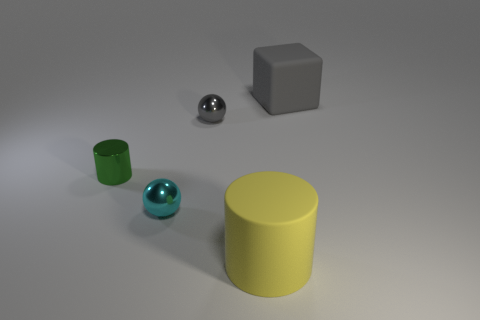There is a thing that is to the right of the big yellow rubber cylinder; how many large objects are on the right side of it?
Provide a succinct answer. 0. What number of big objects have the same material as the small green object?
Make the answer very short. 0. There is a big gray object; are there any balls right of it?
Offer a very short reply. No. There is a rubber cylinder that is the same size as the gray block; what color is it?
Keep it short and to the point. Yellow. How many objects are either small shiny things that are behind the metallic cylinder or tiny green metal objects?
Keep it short and to the point. 2. How big is the thing that is both behind the cyan ball and to the right of the tiny gray ball?
Offer a terse response. Large. The shiny sphere that is the same color as the large matte block is what size?
Provide a succinct answer. Small. How many other things are the same size as the green metallic cylinder?
Make the answer very short. 2. There is a big thing that is in front of the thing to the right of the rubber thing in front of the big block; what color is it?
Keep it short and to the point. Yellow. What shape is the object that is both behind the green shiny cylinder and in front of the matte block?
Ensure brevity in your answer.  Sphere. 